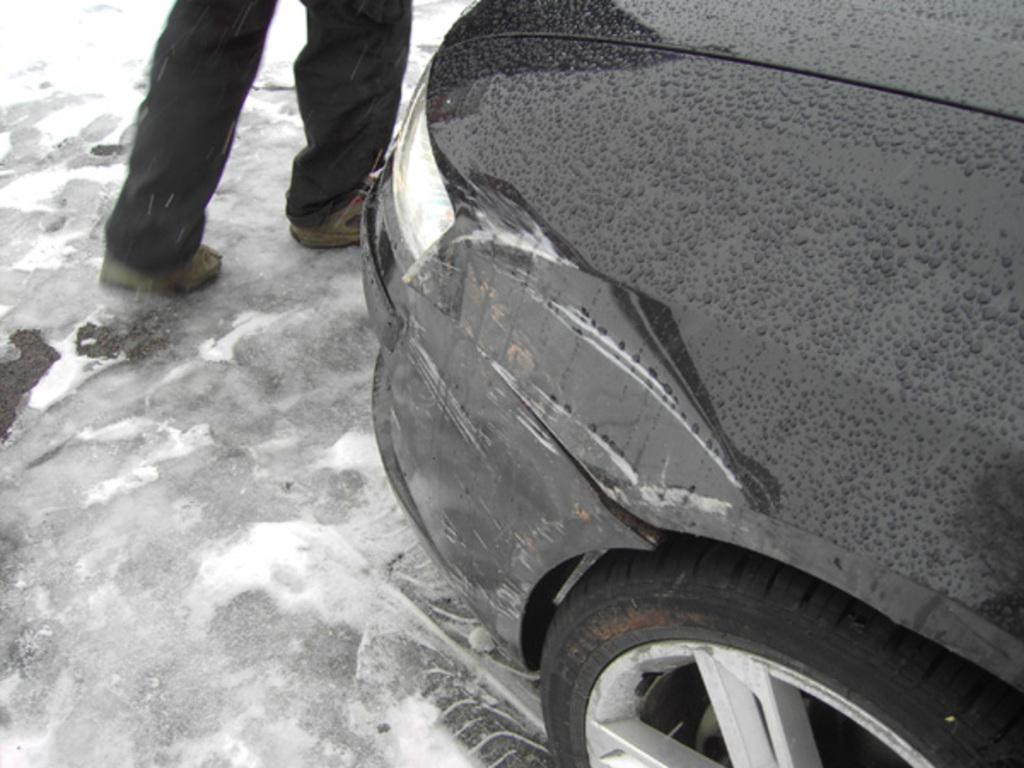What is the person in the image doing? The person in the image is walking on the road. What is the weather like in the image? It is raining in the image. Can you see any vehicles in the image? Yes, part of a car is visible on the right side of the image. Where is the girl playing with soap in the image? There is no girl playing with soap in the image. Is there a drain visible in the image? There is no drain visible in the image. 